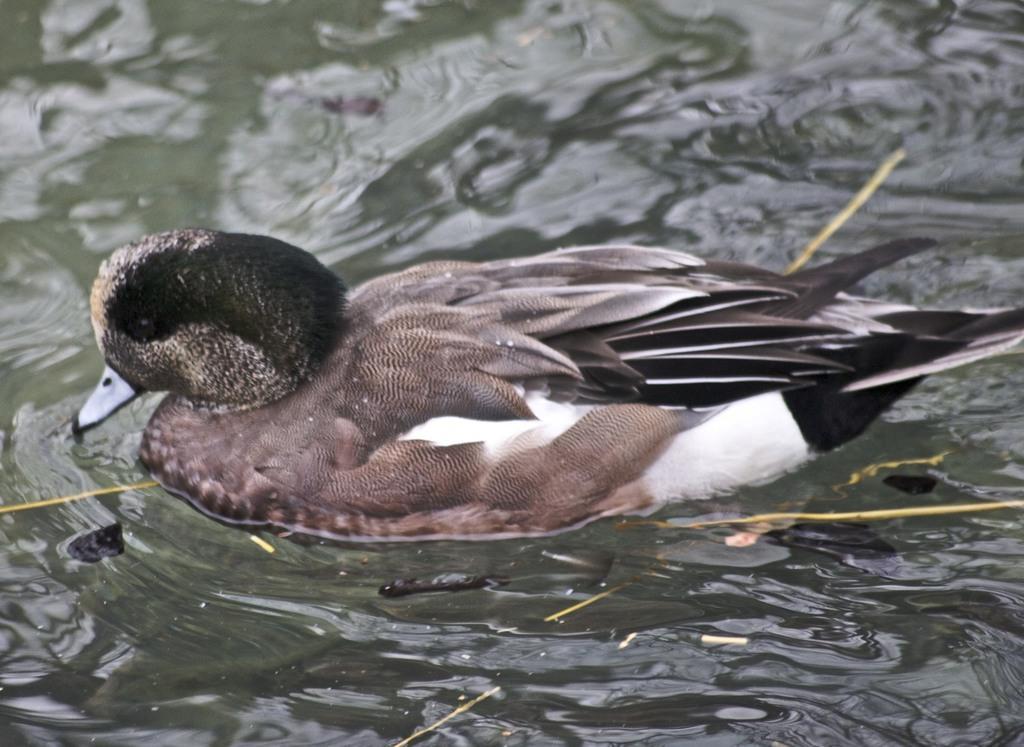Describe this image in one or two sentences. This picture is clicked outside. In the center we can see a bird seems to be the duck swimming in the water body and we can see some other objects in the water body. 